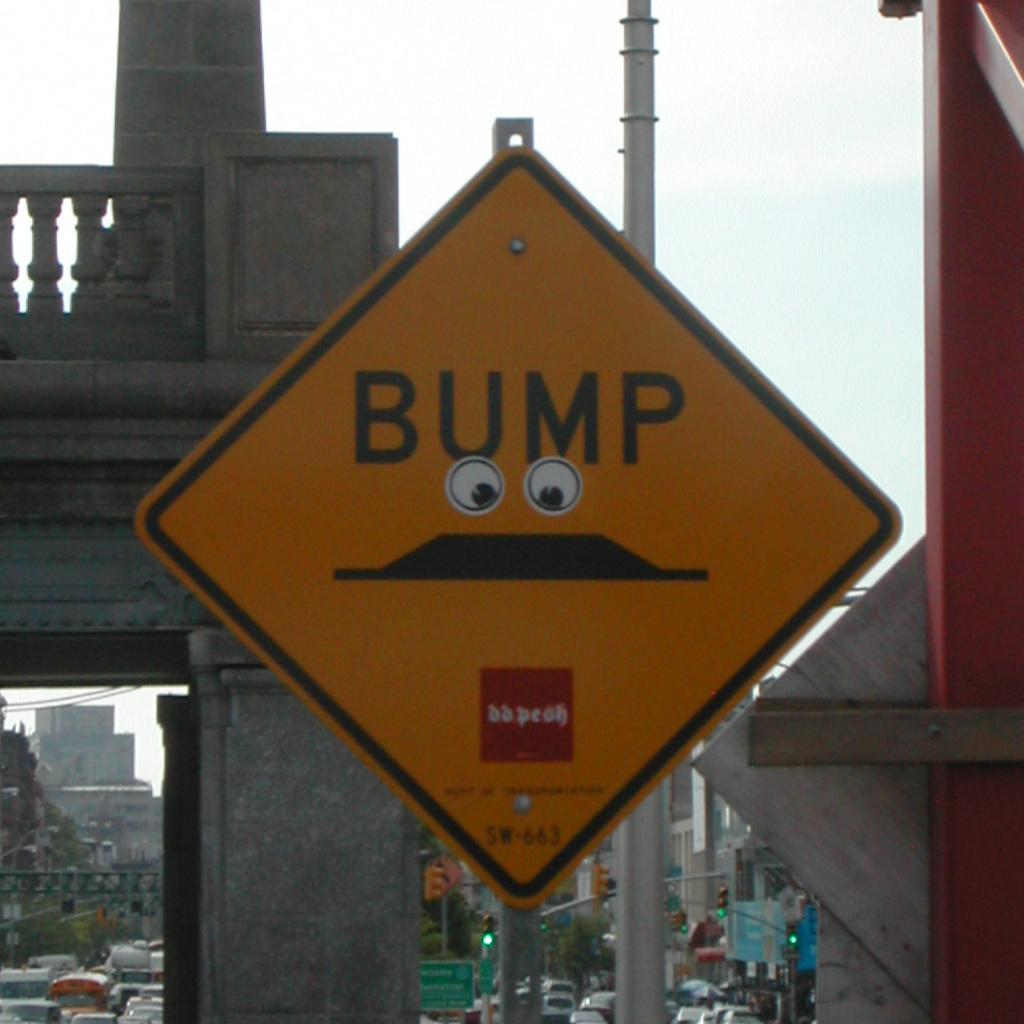<image>
Provide a brief description of the given image. A street sign for BUMP is adorned with googly eyes. 